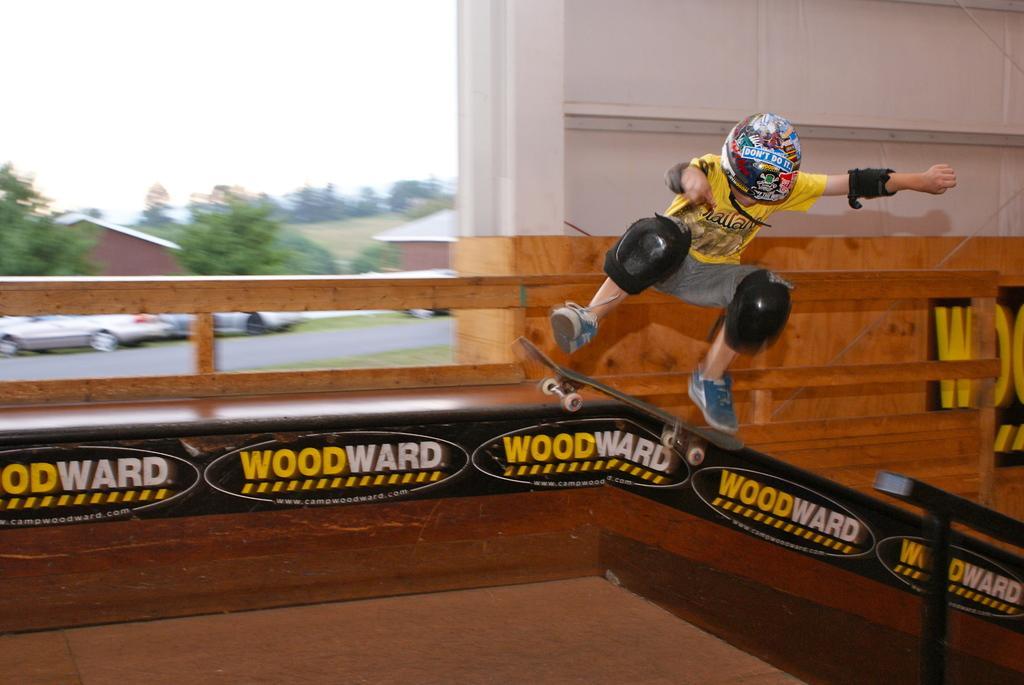Describe this image in one or two sentences. In the foreground of this image, there is a boy wearing helmet, knee pads is skating and he is in the air. At the bottom, there is the floor and railing. Behind him, there is a wall and in the background, there are trees, houses vehicles, road and the sky. 